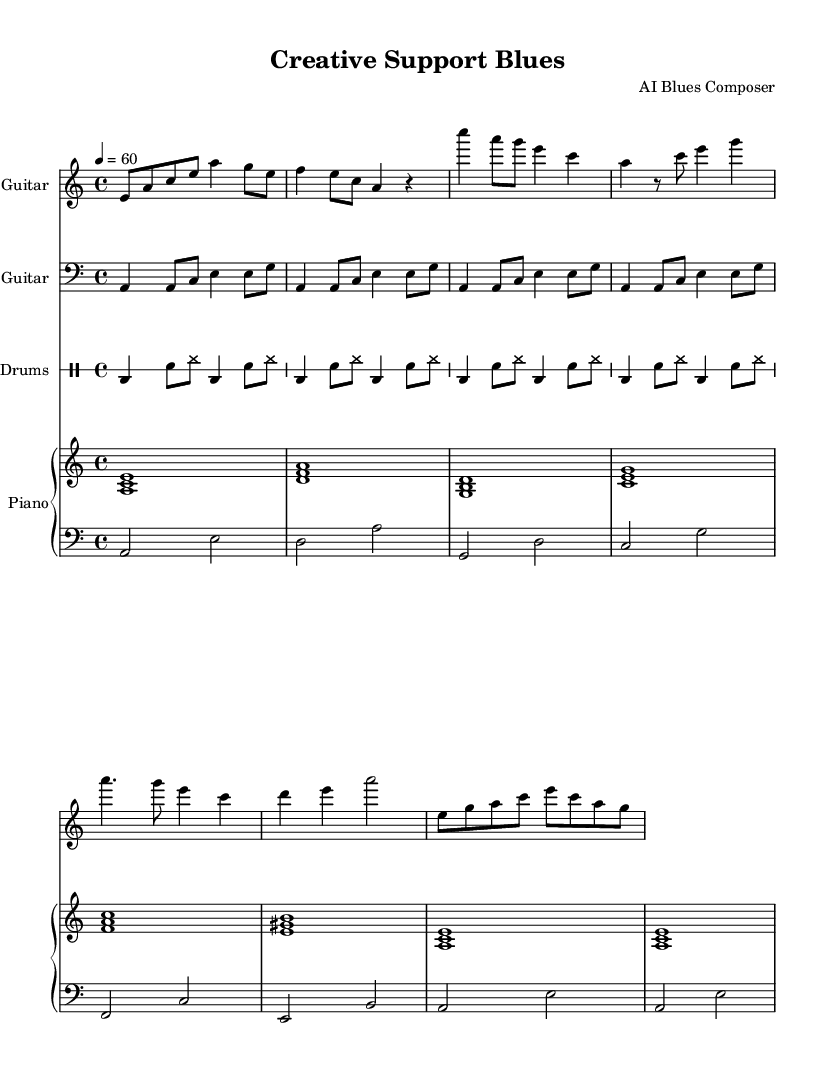What is the key signature of this music? The key signature is indicated at the beginning of the music, showing no sharps or flats, which identifies it as A minor.
Answer: A minor What is the time signature of this music? The time signature is shown at the beginning of the sheet music, with a numerator of 4 and a denominator of 4, indicating a four beat measure.
Answer: 4/4 What is the tempo marking for this piece? The tempo is indicated by the marking 4 = 60, meaning that there are sixty quarter note beats per minute.
Answer: 60 How many measures are there in the electric guitar part? By counting each segment in the electric guitar line, there are a total of eight measures present.
Answer: 8 What is the primary instrument used for rhythm in this piece? The instrument most typically associated with rhythm in this genre and in this arrangement is the electric guitar, as it lays down the harmonic and melodic foundation.
Answer: Electric Guitar What is the mood conveyed through the music style? The structure and sound of the electric blues ballad, particularly focusing on support and emotion, convey a soulful and emotive mood emphasized by the instrument choices.
Answer: Soulful Which instruments are included in the arrangement? The arrangement consists of electric guitar, bass guitar, drums, and piano, all contributing to the overall sound of the piece.
Answer: Electric Guitar, Bass Guitar, Drums, Piano 